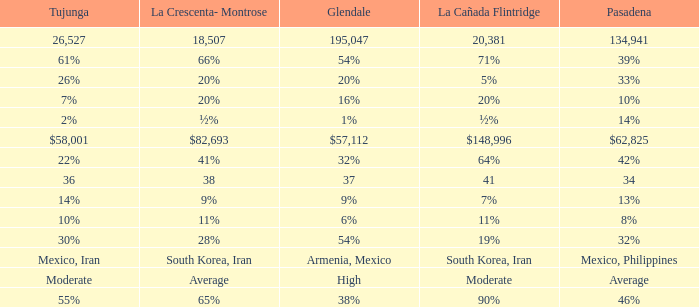When tujunga is temperate, what is la crescenta-montrose? Average. 